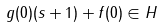<formula> <loc_0><loc_0><loc_500><loc_500>g ( 0 ) ( s + 1 ) + f ( 0 ) \in H</formula> 